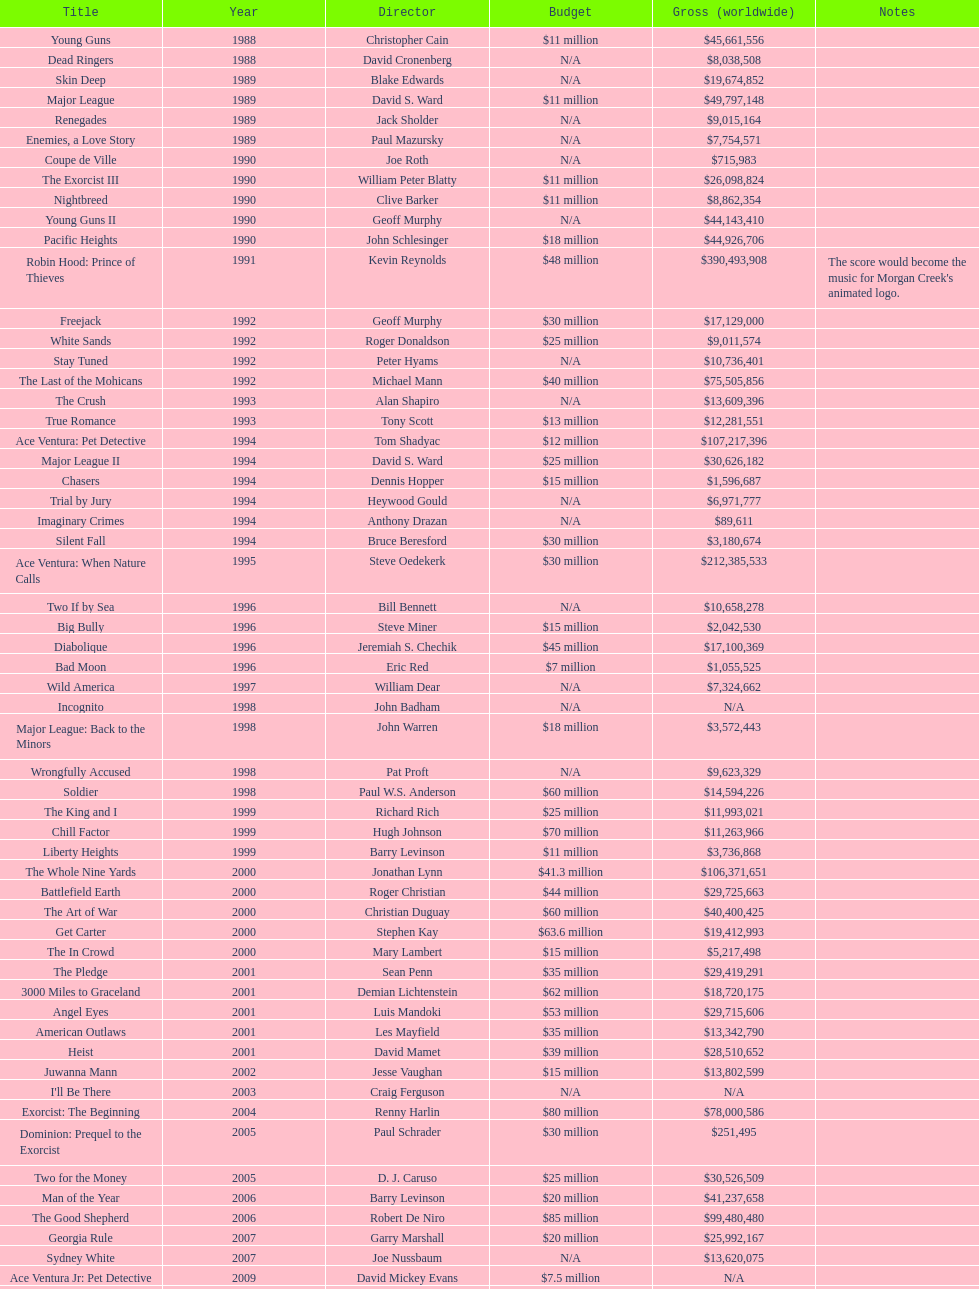What was the subsequent movie with the same budget as young guns? Major League. 